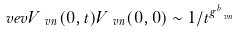<formula> <loc_0><loc_0><loc_500><loc_500>\ v e v { V _ { \ v n } ( 0 , t ) V _ { \ v n } ( 0 , 0 ) } \sim 1 / t ^ { g ^ { b } _ { \ v n } }</formula> 